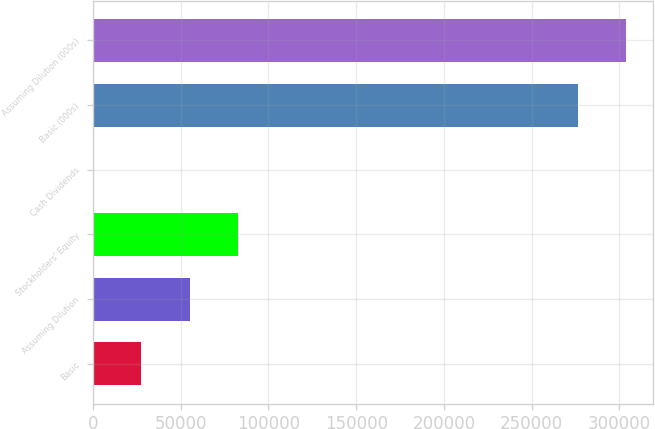Convert chart. <chart><loc_0><loc_0><loc_500><loc_500><bar_chart><fcel>Basic<fcel>Assuming Dilution<fcel>Stockholders' Equity<fcel>Cash Dividends<fcel>Basic (000s)<fcel>Assuming Dilution (000s)<nl><fcel>27613.5<fcel>55226.7<fcel>82839.9<fcel>0.37<fcel>276132<fcel>303745<nl></chart> 